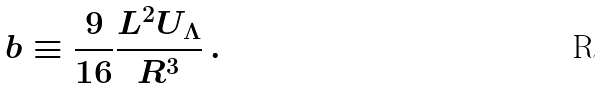<formula> <loc_0><loc_0><loc_500><loc_500>b \equiv \frac { 9 } { 1 6 } \frac { L ^ { 2 } U _ { \Lambda } } { R ^ { 3 } } \, .</formula> 